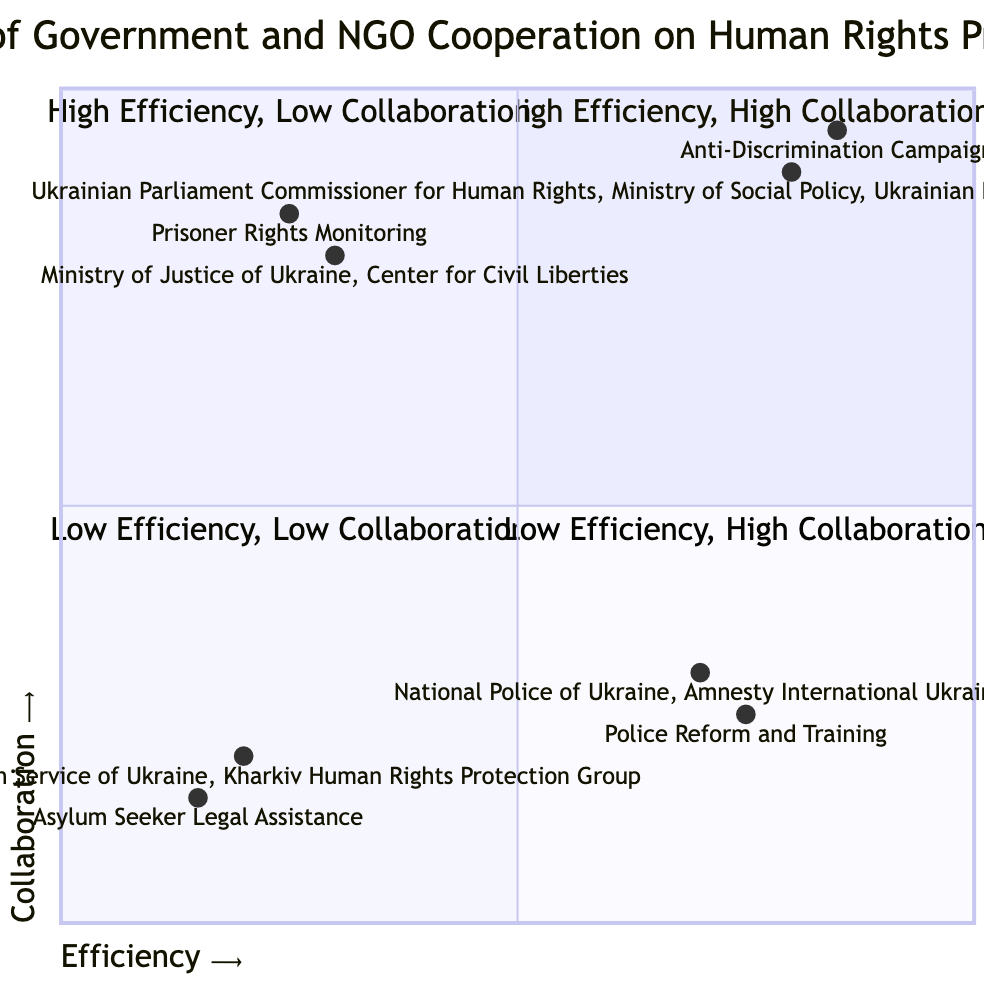What are the government entities in the high efficiency, high collaboration quadrant? In the high efficiency, high collaboration quadrant, the listed government entities are the Ukrainian Parliament Commissioner for Human Rights and the Ministry of Social Policy.
Answer: Ukrainian Parliament Commissioner for Human Rights, Ministry of Social Policy How many example projects are in the low efficiency, low collaboration quadrant? There is one example project listed in the low efficiency, low collaboration quadrant, which is the Asylum Seeker Legal Assistance project.
Answer: 1 Which NGO is collaborating with the Ministry of Justice of Ukraine? The NGO collaborating with the Ministry of Justice of Ukraine is the Center for Civil Liberties.
Answer: Center for Civil Liberties What is the efficiency rating of the Police Reform and Training project? The efficiency rating of the Police Reform and Training project is 0.75.
Answer: 0.75 What does the term "high collaboration" indicate in this diagram? "High collaboration" indicates that there is a significant level of cooperation between government entities and NGOs on human rights projects, as represented in the upper quadrants of the chart.
Answer: Significant cooperation In the quadrant with low efficiency and high collaboration, which example project is indicated? The example project indicated in the low efficiency and high collaboration quadrant is the Prisoner Rights Monitoring project.
Answer: Prisoner Rights Monitoring Which quadrant includes the National Police of Ukraine? The National Police of Ukraine is located in the high efficiency, low collaboration quadrant.
Answer: High Efficiency, Low Collaboration How many NGO entities are listed in the high efficiency, high collaboration quadrant? There are two NGO entities listed in the high efficiency, high collaboration quadrant: Ukrainian Helsinki Human Rights Union and Freedom House Ukraine.
Answer: 2 What is the collaboration level of the State Migration Service of Ukraine? The collaboration level of the State Migration Service of Ukraine is low, as it resides in the low efficiency, low collaboration quadrant.
Answer: Low How does the efficiency of the Ukrainian Helsinki Human Rights Union compare to the Center for Civil Liberties? The efficiency of the Ukrainian Helsinki Human Rights Union (0.8) is higher than that of the Center for Civil Liberties (0.3).
Answer: Higher 